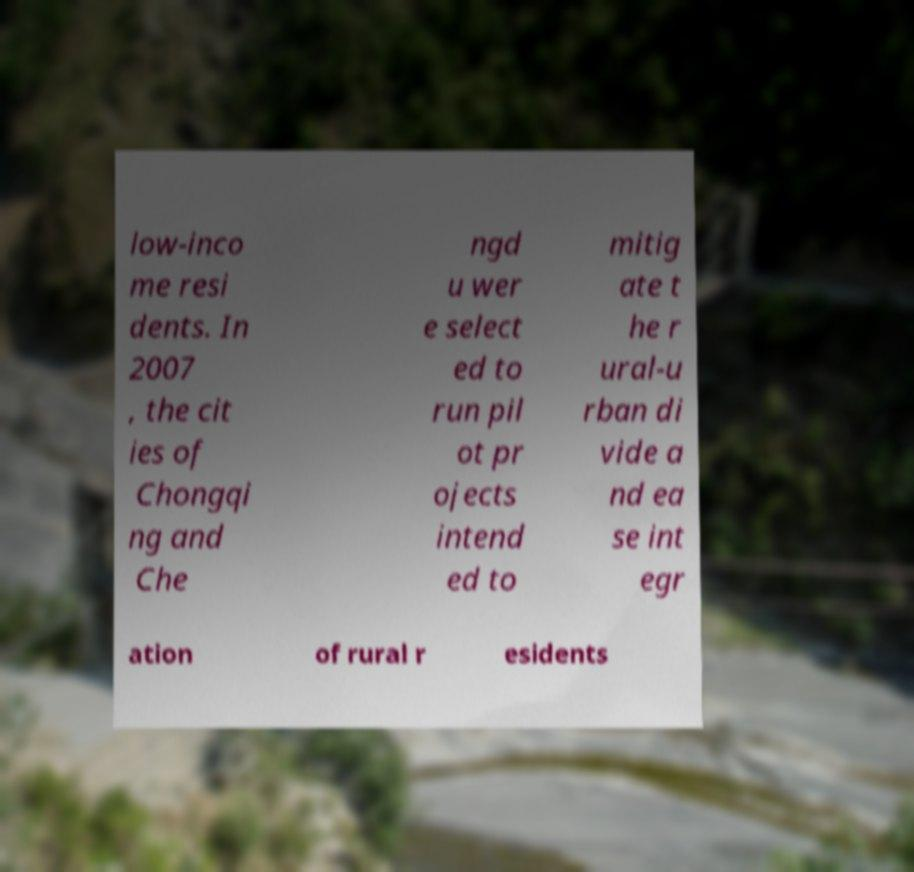Can you read and provide the text displayed in the image?This photo seems to have some interesting text. Can you extract and type it out for me? low-inco me resi dents. In 2007 , the cit ies of Chongqi ng and Che ngd u wer e select ed to run pil ot pr ojects intend ed to mitig ate t he r ural-u rban di vide a nd ea se int egr ation of rural r esidents 